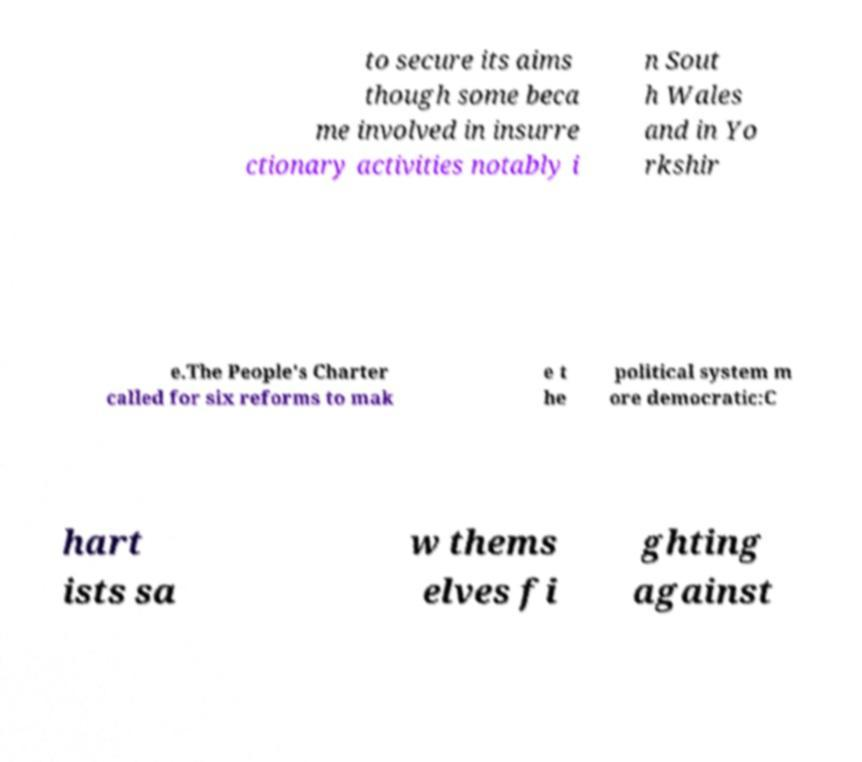Could you extract and type out the text from this image? to secure its aims though some beca me involved in insurre ctionary activities notably i n Sout h Wales and in Yo rkshir e.The People's Charter called for six reforms to mak e t he political system m ore democratic:C hart ists sa w thems elves fi ghting against 